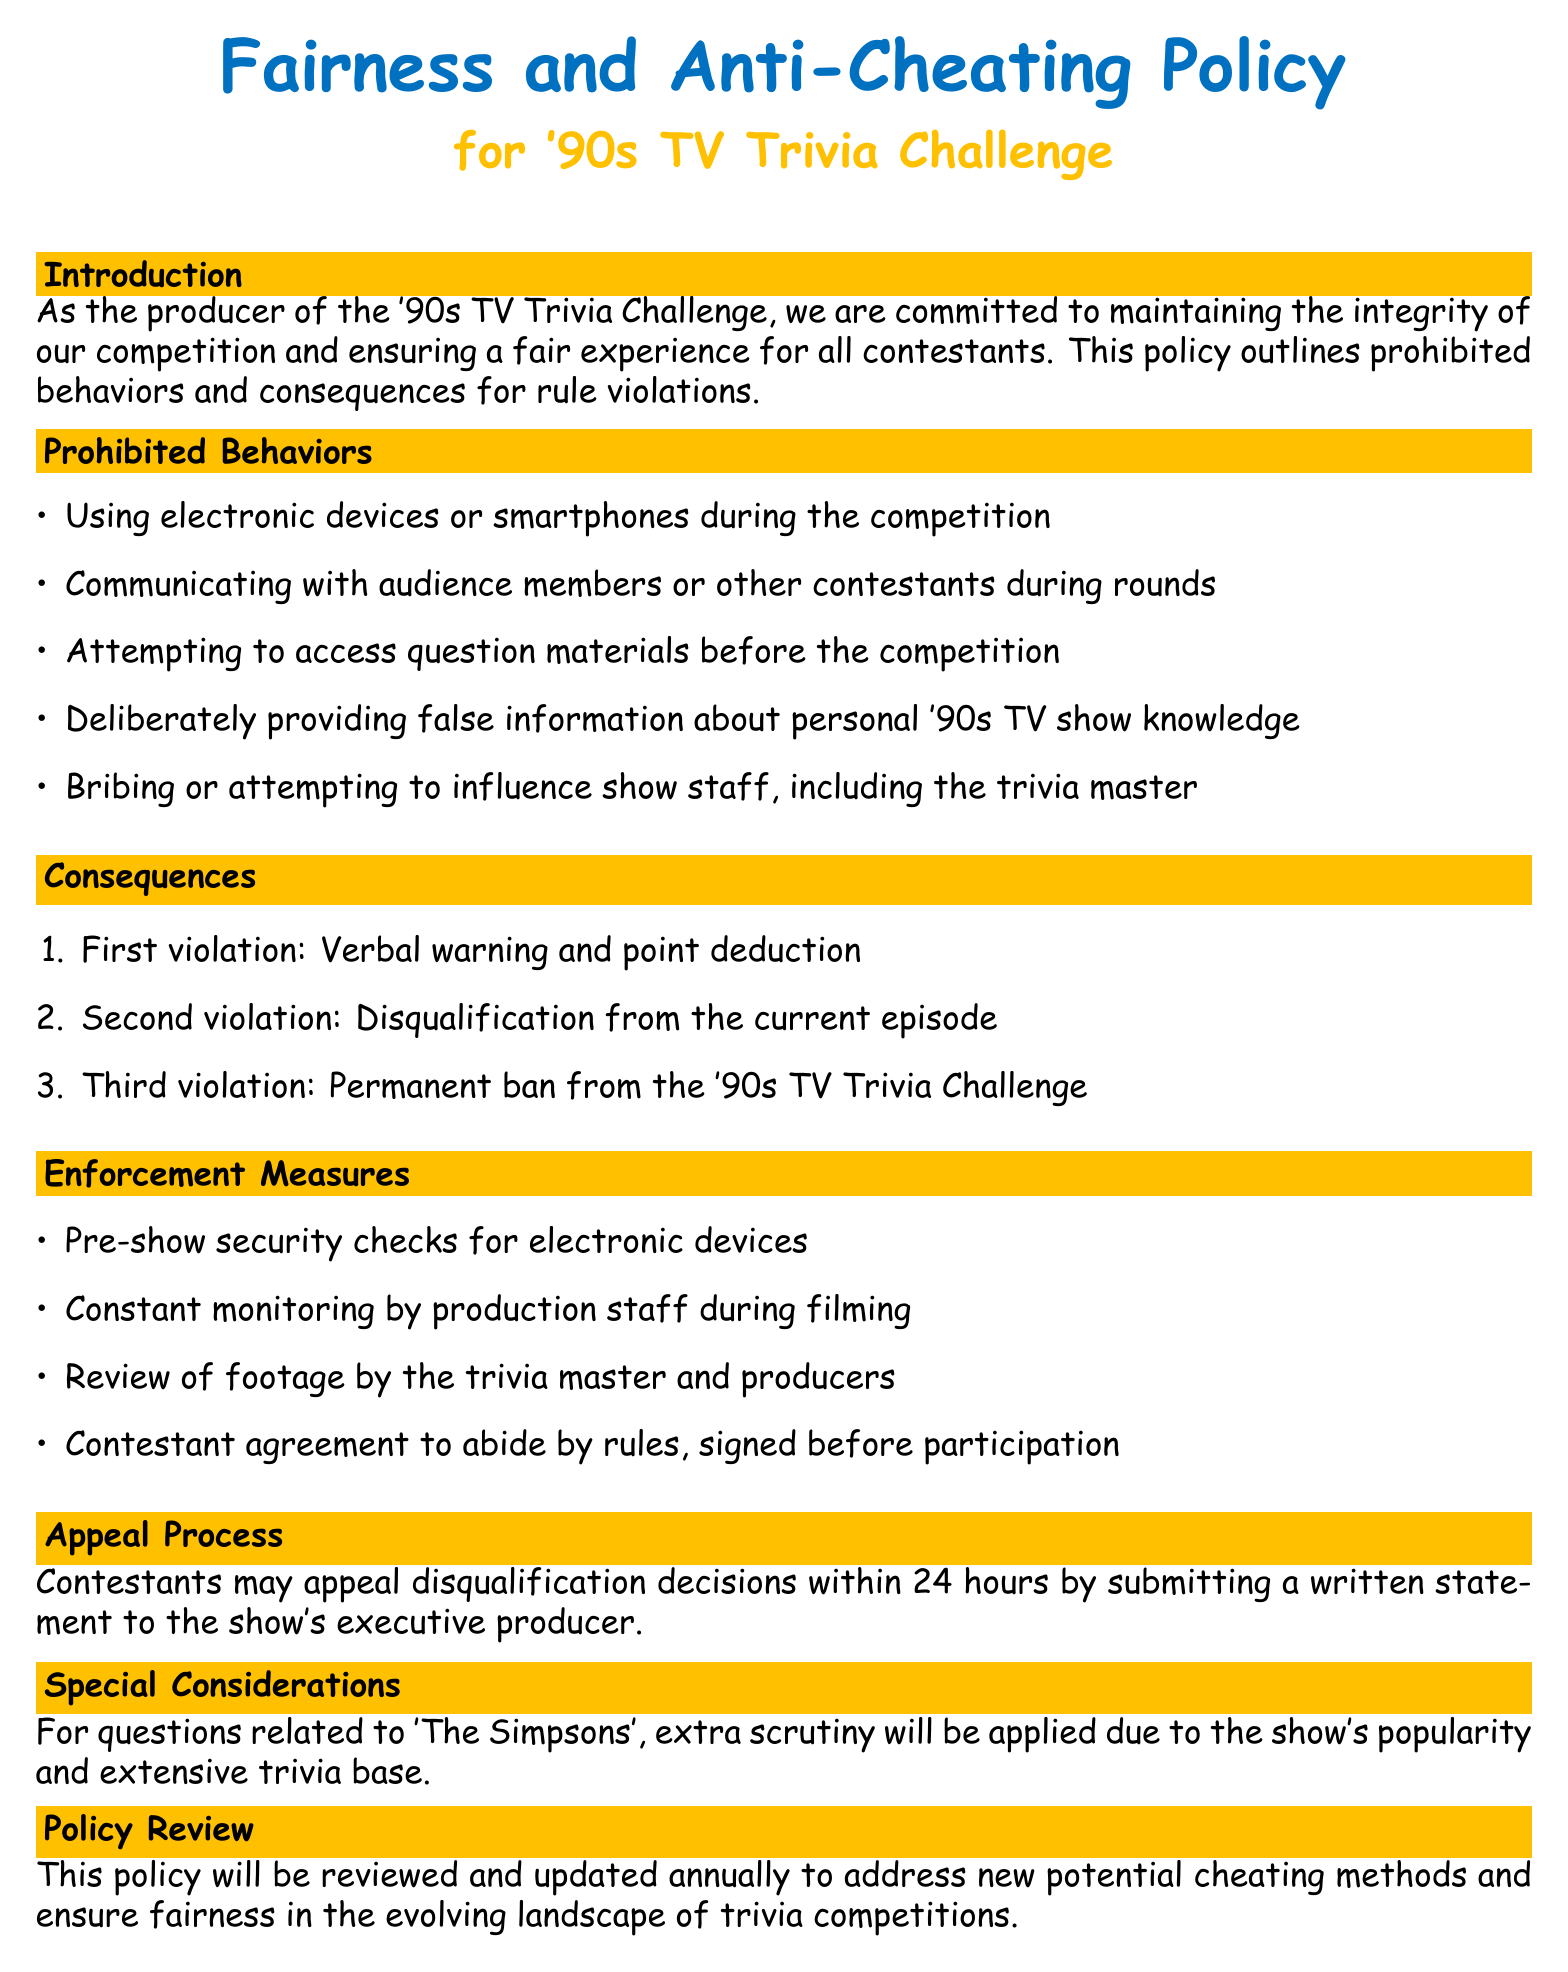What is the main purpose of the policy? The main purpose of the policy is to maintain the integrity of the competition and ensure a fair experience for all contestants.
Answer: maintain integrity What is one prohibited behavior during the competition? The document lists several prohibited behaviors, one of which is using electronic devices or smartphones during the competition.
Answer: using electronic devices What is the consequence of a first violation? The first violation results in a verbal warning and point deduction as stated in the document.
Answer: verbal warning and point deduction How long do contestants have to appeal disqualification decisions? Contestants may appeal disqualification decisions within 24 hours, as specified in the document.
Answer: 24 hours What happens after a third violation? A third violation leads to a permanent ban from the '90s TV Trivia Challenge, according to the outlined consequences.
Answer: permanent ban Which show receives extra scrutiny in the policy? The policy specifies that extra scrutiny will be applied for questions related to 'The Simpsons'.
Answer: 'The Simpsons' How often will the policy be reviewed? The document states that the policy will be reviewed and updated annually.
Answer: annually 